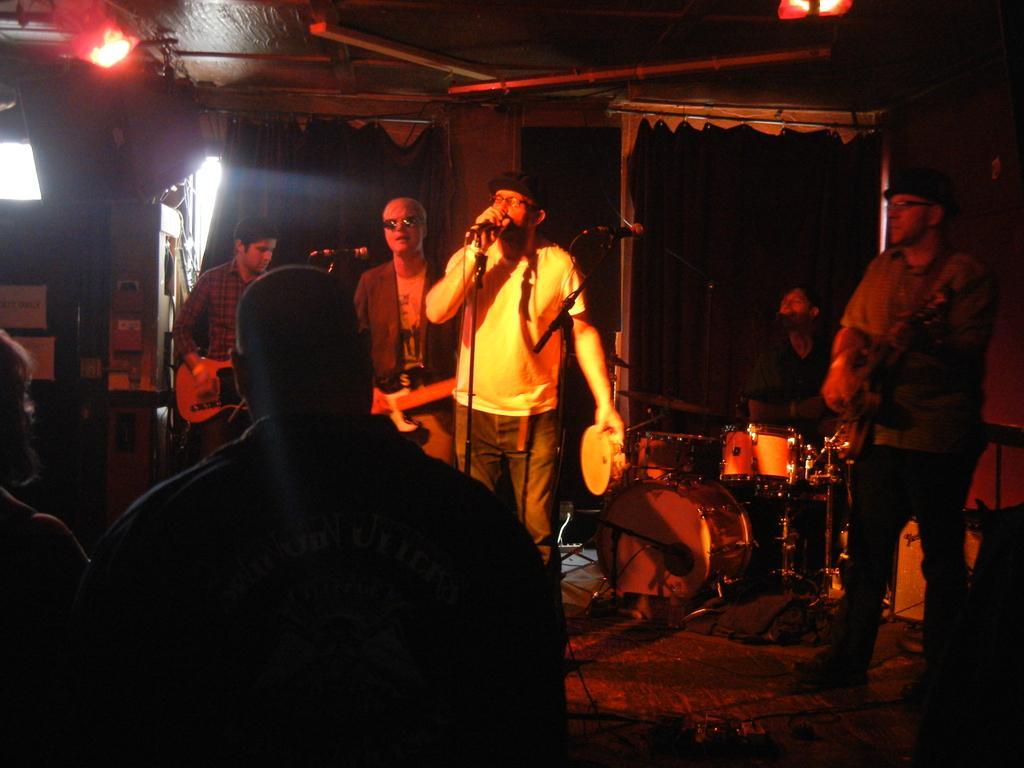How would you summarize this image in a sentence or two? In this picture we can see four people playing musical instruments the man on the right side of the image playing guitar the man behind him is holding a microphone, the man on the left is also playing a guitar, in front there are two persons looking at looking at the man holding a microphone, in the background we can see a man sitting and playing drums on the top of the image we can see some lights. 